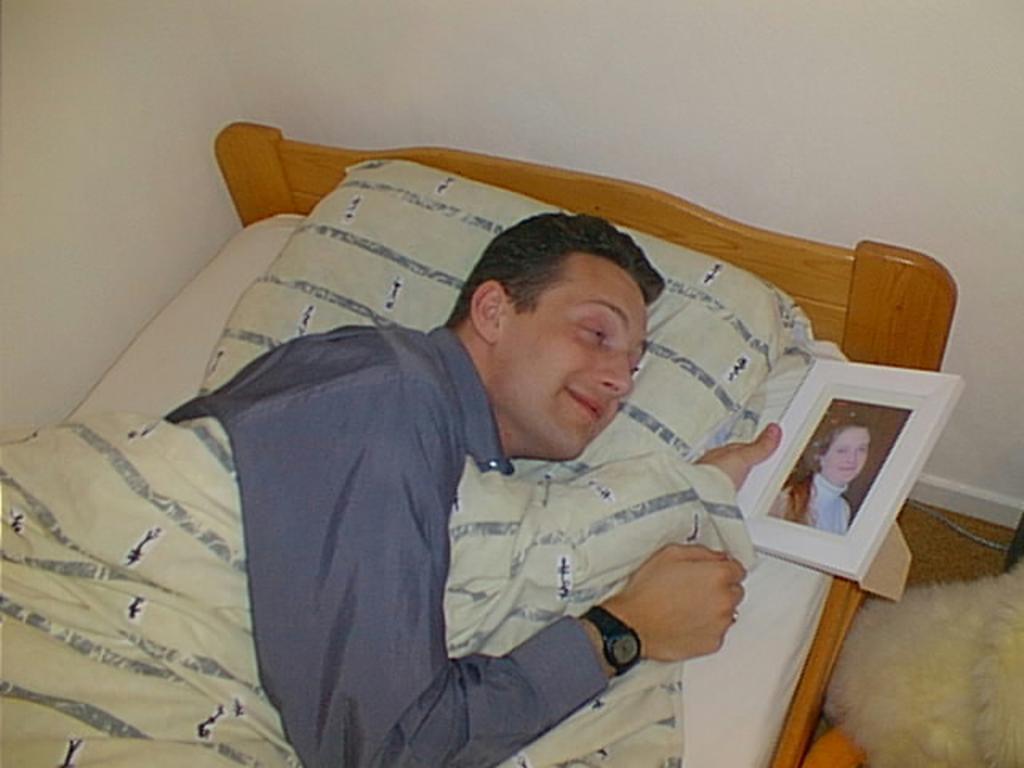Can you describe this image briefly? In this image I can see a man lying on the bed and holding a frame. 